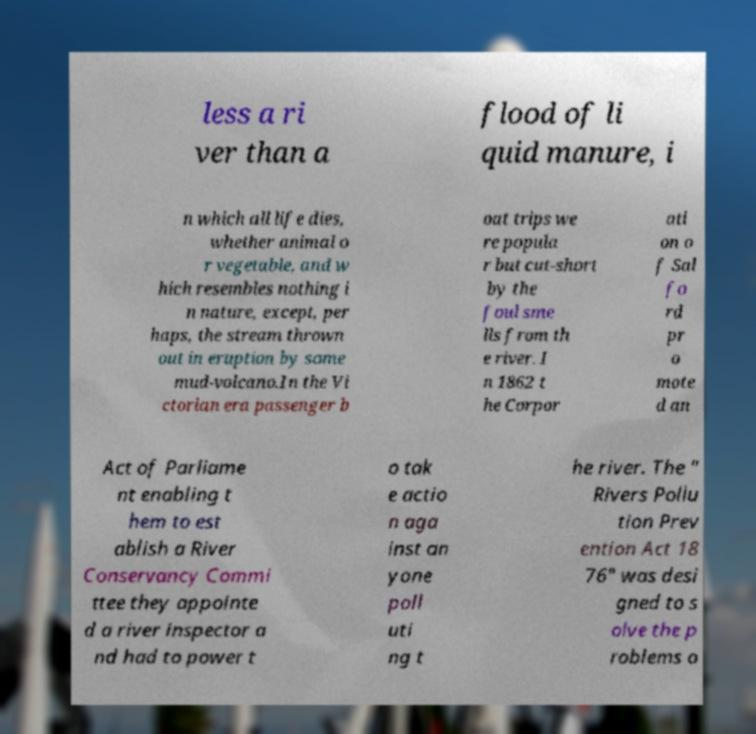Please identify and transcribe the text found in this image. less a ri ver than a flood of li quid manure, i n which all life dies, whether animal o r vegetable, and w hich resembles nothing i n nature, except, per haps, the stream thrown out in eruption by some mud-volcano.In the Vi ctorian era passenger b oat trips we re popula r but cut-short by the foul sme lls from th e river. I n 1862 t he Corpor ati on o f Sal fo rd pr o mote d an Act of Parliame nt enabling t hem to est ablish a River Conservancy Commi ttee they appointe d a river inspector a nd had to power t o tak e actio n aga inst an yone poll uti ng t he river. The " Rivers Pollu tion Prev ention Act 18 76" was desi gned to s olve the p roblems o 